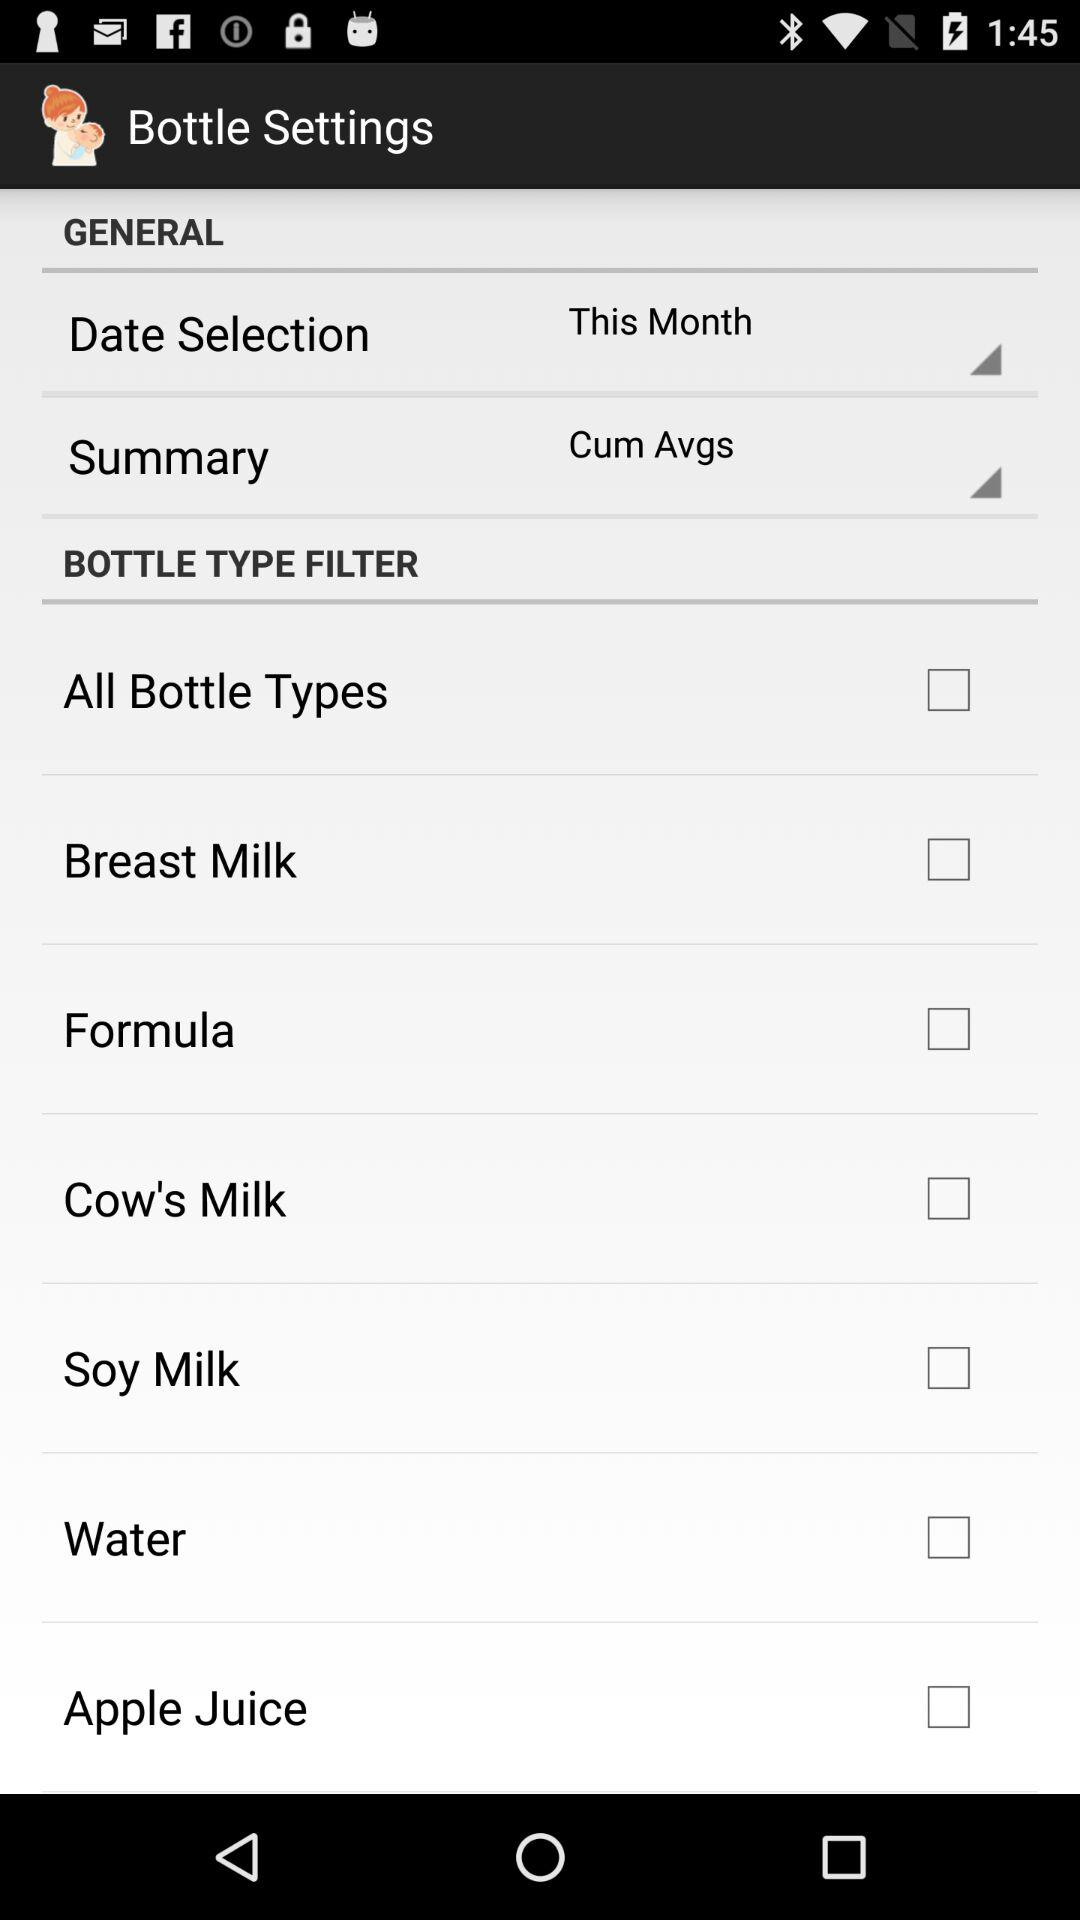How many bottle types are not checked?
Answer the question using a single word or phrase. 7 